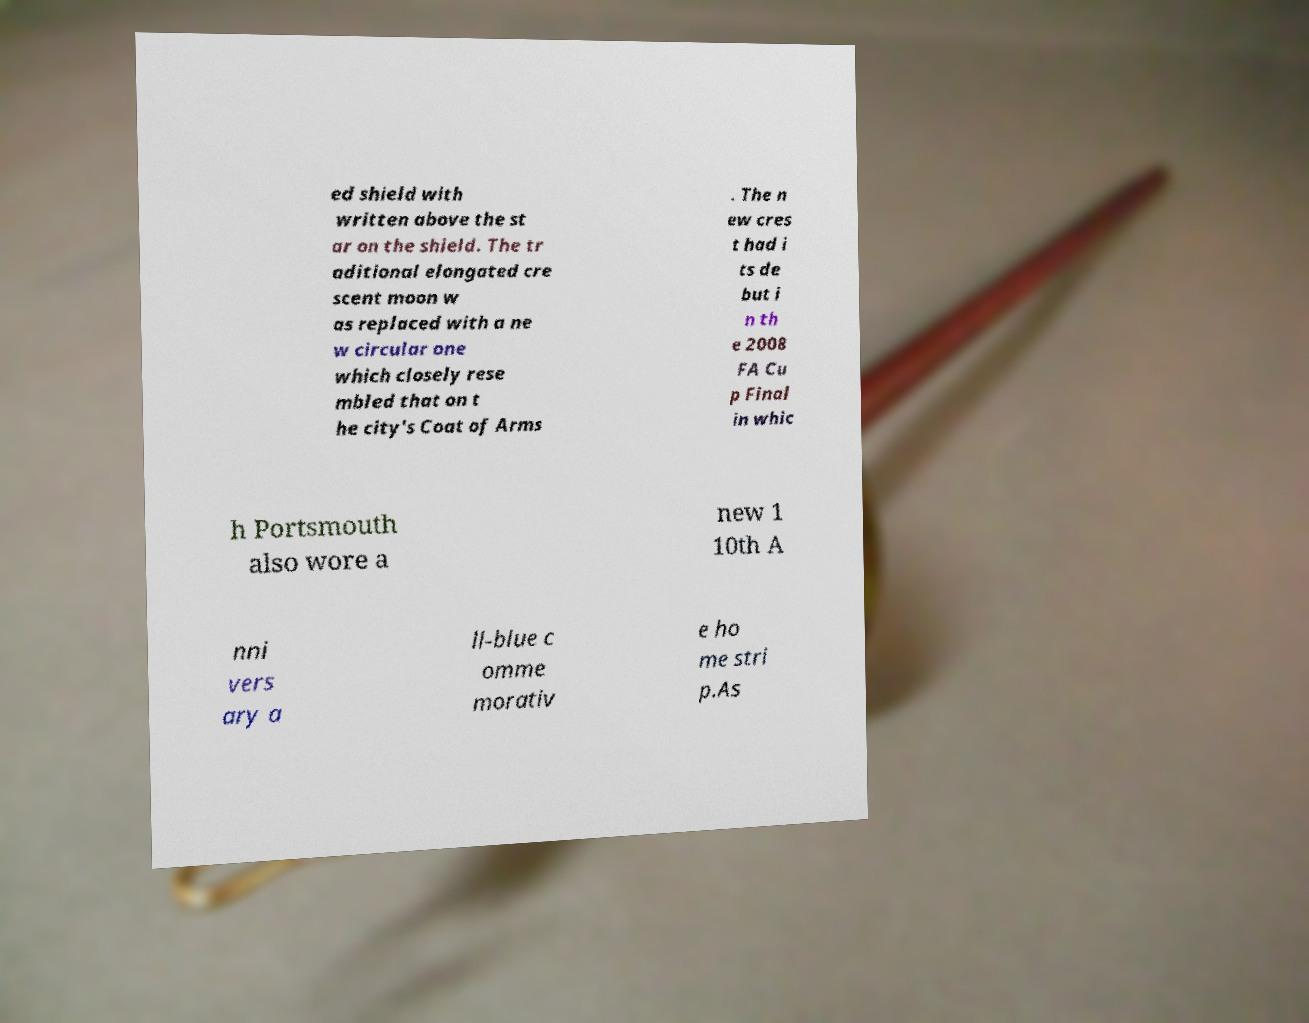Please read and relay the text visible in this image. What does it say? ed shield with written above the st ar on the shield. The tr aditional elongated cre scent moon w as replaced with a ne w circular one which closely rese mbled that on t he city's Coat of Arms . The n ew cres t had i ts de but i n th e 2008 FA Cu p Final in whic h Portsmouth also wore a new 1 10th A nni vers ary a ll-blue c omme morativ e ho me stri p.As 